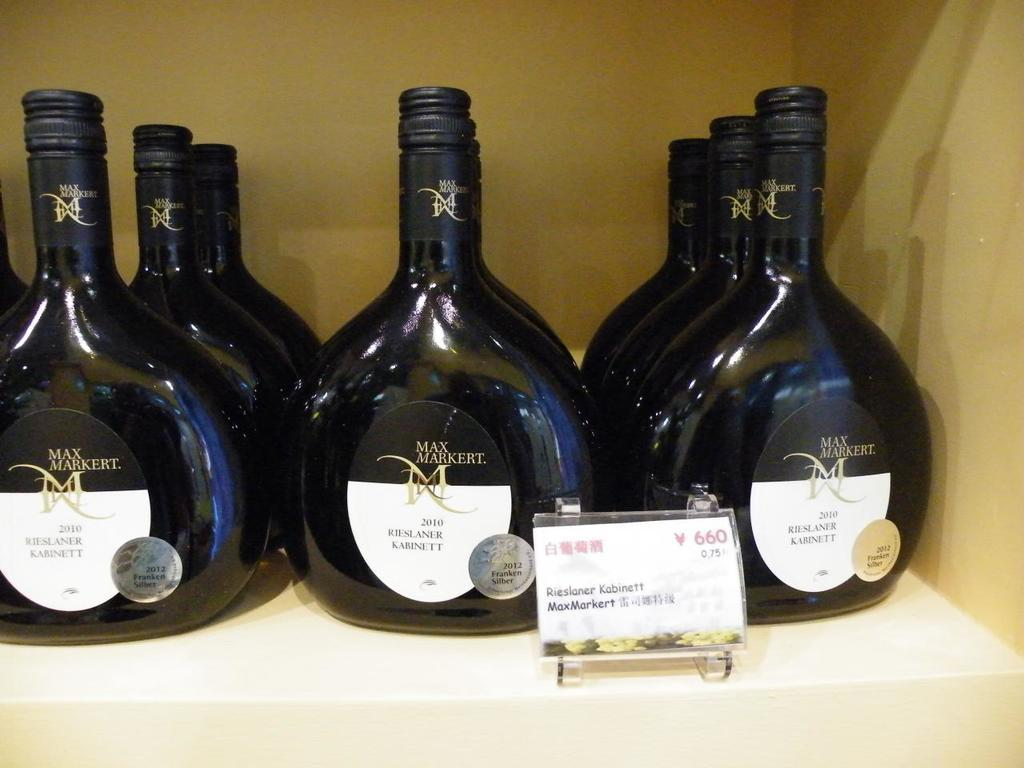<image>
Relay a brief, clear account of the picture shown. Nine bottles of Max Markert product sit on a store shelf. 